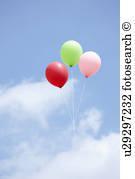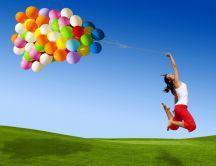The first image is the image on the left, the second image is the image on the right. Evaluate the accuracy of this statement regarding the images: "There are two other colored balloons with a yellow balloon in the right image.". Is it true? Answer yes or no. No. The first image is the image on the left, the second image is the image on the right. Considering the images on both sides, is "An image shows at least one person being lifted by means of balloon." valid? Answer yes or no. Yes. 